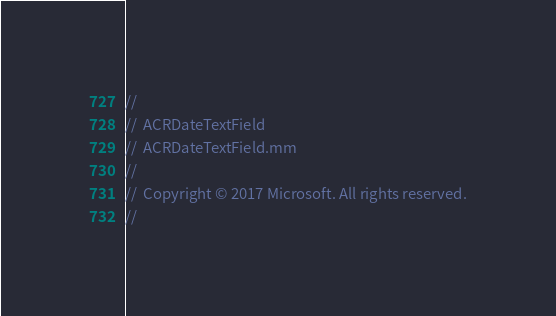<code> <loc_0><loc_0><loc_500><loc_500><_ObjectiveC_>//
//  ACRDateTextField
//  ACRDateTextField.mm
//
//  Copyright © 2017 Microsoft. All rights reserved.
//
</code> 